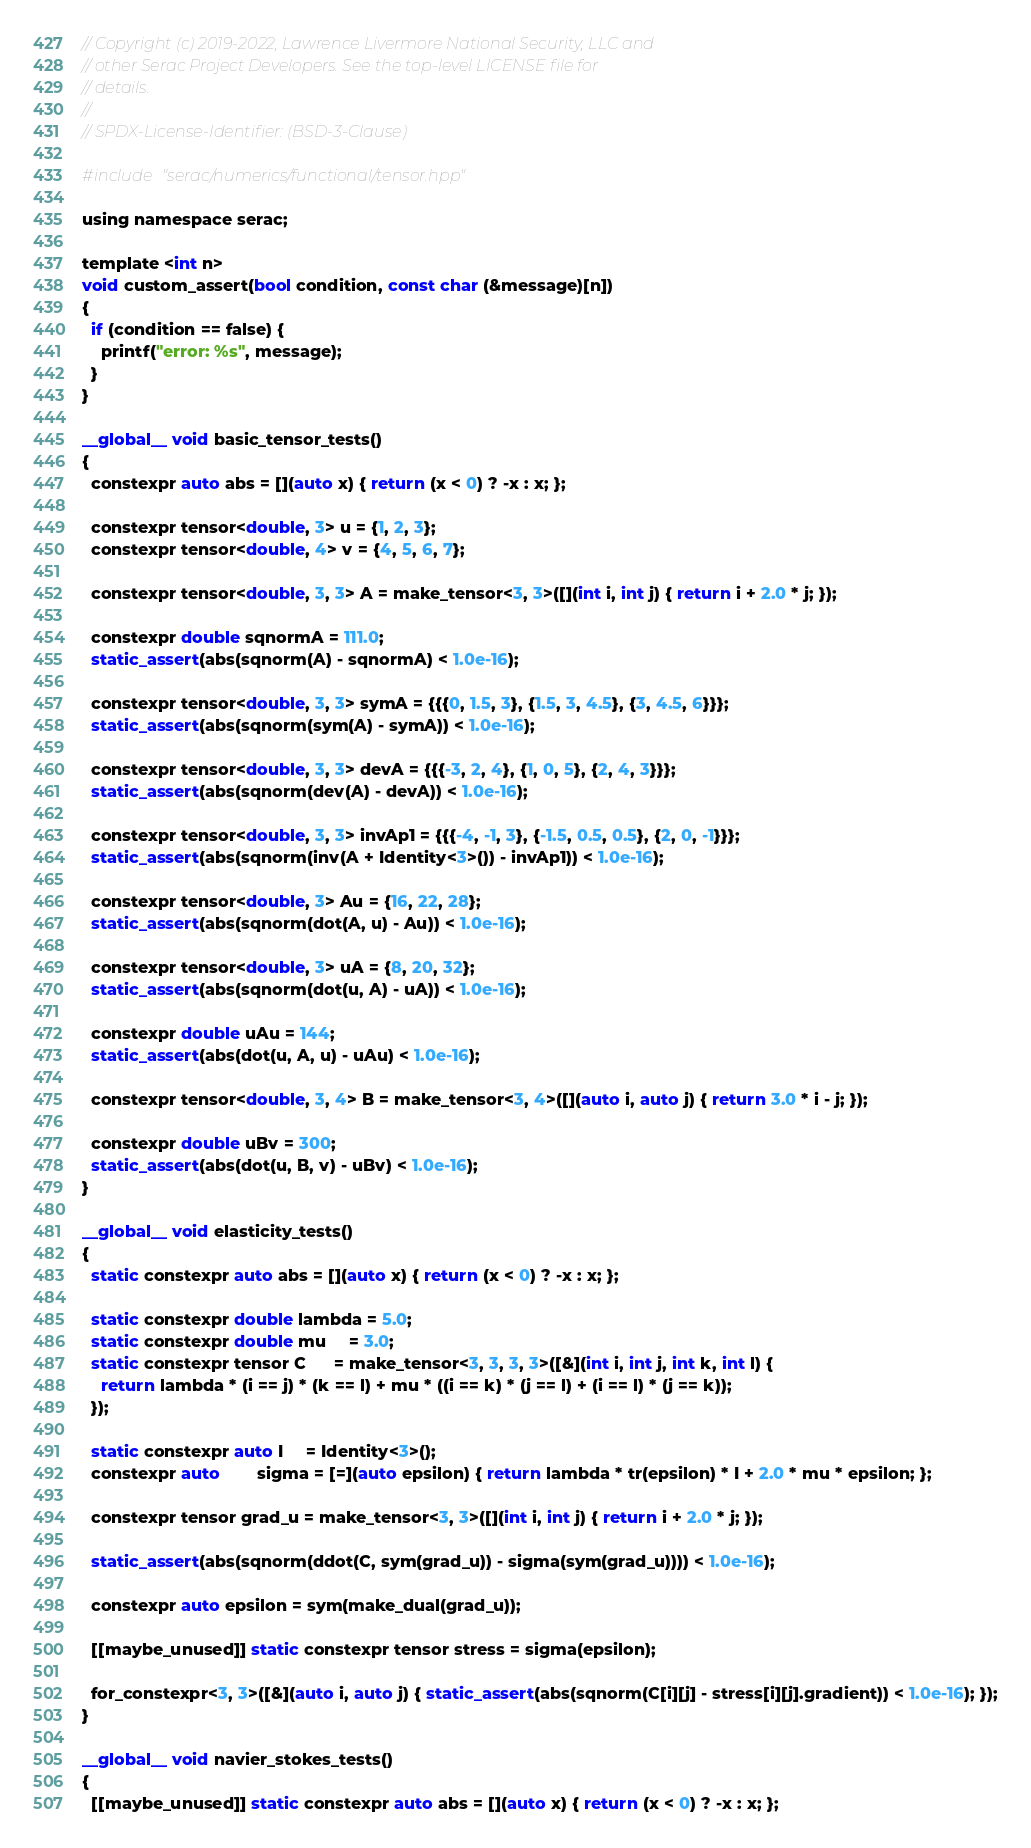Convert code to text. <code><loc_0><loc_0><loc_500><loc_500><_Cuda_>// Copyright (c) 2019-2022, Lawrence Livermore National Security, LLC and
// other Serac Project Developers. See the top-level LICENSE file for
// details.
//
// SPDX-License-Identifier: (BSD-3-Clause)

#include "serac/numerics/functional/tensor.hpp"

using namespace serac;

template <int n>
void custom_assert(bool condition, const char (&message)[n])
{
  if (condition == false) {
    printf("error: %s", message);
  }
}

__global__ void basic_tensor_tests()
{
  constexpr auto abs = [](auto x) { return (x < 0) ? -x : x; };

  constexpr tensor<double, 3> u = {1, 2, 3};
  constexpr tensor<double, 4> v = {4, 5, 6, 7};

  constexpr tensor<double, 3, 3> A = make_tensor<3, 3>([](int i, int j) { return i + 2.0 * j; });

  constexpr double sqnormA = 111.0;
  static_assert(abs(sqnorm(A) - sqnormA) < 1.0e-16);

  constexpr tensor<double, 3, 3> symA = {{{0, 1.5, 3}, {1.5, 3, 4.5}, {3, 4.5, 6}}};
  static_assert(abs(sqnorm(sym(A) - symA)) < 1.0e-16);

  constexpr tensor<double, 3, 3> devA = {{{-3, 2, 4}, {1, 0, 5}, {2, 4, 3}}};
  static_assert(abs(sqnorm(dev(A) - devA)) < 1.0e-16);

  constexpr tensor<double, 3, 3> invAp1 = {{{-4, -1, 3}, {-1.5, 0.5, 0.5}, {2, 0, -1}}};
  static_assert(abs(sqnorm(inv(A + Identity<3>()) - invAp1)) < 1.0e-16);

  constexpr tensor<double, 3> Au = {16, 22, 28};
  static_assert(abs(sqnorm(dot(A, u) - Au)) < 1.0e-16);

  constexpr tensor<double, 3> uA = {8, 20, 32};
  static_assert(abs(sqnorm(dot(u, A) - uA)) < 1.0e-16);

  constexpr double uAu = 144;
  static_assert(abs(dot(u, A, u) - uAu) < 1.0e-16);

  constexpr tensor<double, 3, 4> B = make_tensor<3, 4>([](auto i, auto j) { return 3.0 * i - j; });

  constexpr double uBv = 300;
  static_assert(abs(dot(u, B, v) - uBv) < 1.0e-16);
}

__global__ void elasticity_tests()
{
  static constexpr auto abs = [](auto x) { return (x < 0) ? -x : x; };

  static constexpr double lambda = 5.0;
  static constexpr double mu     = 3.0;
  static constexpr tensor C      = make_tensor<3, 3, 3, 3>([&](int i, int j, int k, int l) {
    return lambda * (i == j) * (k == l) + mu * ((i == k) * (j == l) + (i == l) * (j == k));
  });

  static constexpr auto I     = Identity<3>();
  constexpr auto        sigma = [=](auto epsilon) { return lambda * tr(epsilon) * I + 2.0 * mu * epsilon; };

  constexpr tensor grad_u = make_tensor<3, 3>([](int i, int j) { return i + 2.0 * j; });

  static_assert(abs(sqnorm(ddot(C, sym(grad_u)) - sigma(sym(grad_u)))) < 1.0e-16);

  constexpr auto epsilon = sym(make_dual(grad_u));

  [[maybe_unused]] static constexpr tensor stress = sigma(epsilon);

  for_constexpr<3, 3>([&](auto i, auto j) { static_assert(abs(sqnorm(C[i][j] - stress[i][j].gradient)) < 1.0e-16); });
}

__global__ void navier_stokes_tests()
{
  [[maybe_unused]] static constexpr auto abs = [](auto x) { return (x < 0) ? -x : x; };
</code> 